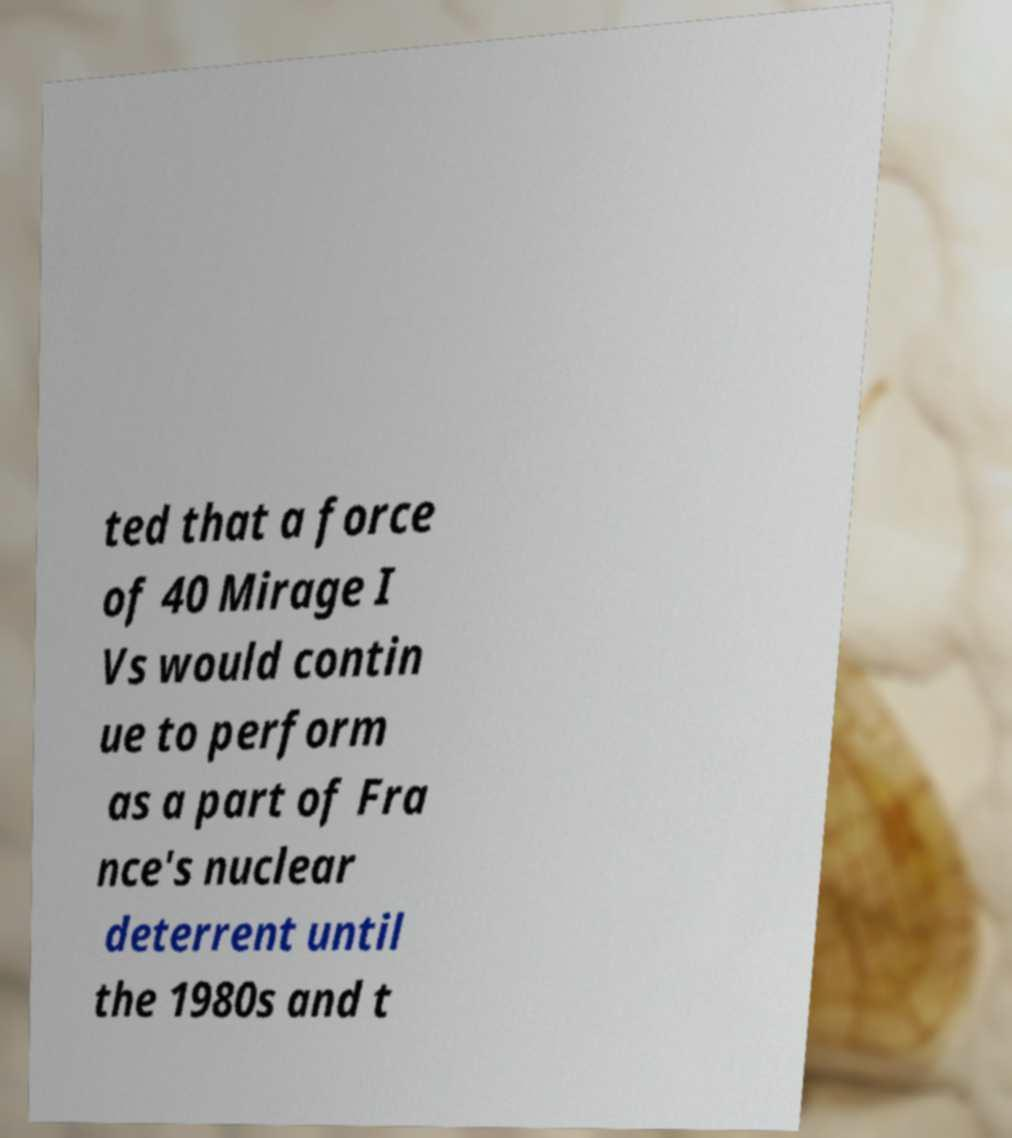Please read and relay the text visible in this image. What does it say? ted that a force of 40 Mirage I Vs would contin ue to perform as a part of Fra nce's nuclear deterrent until the 1980s and t 